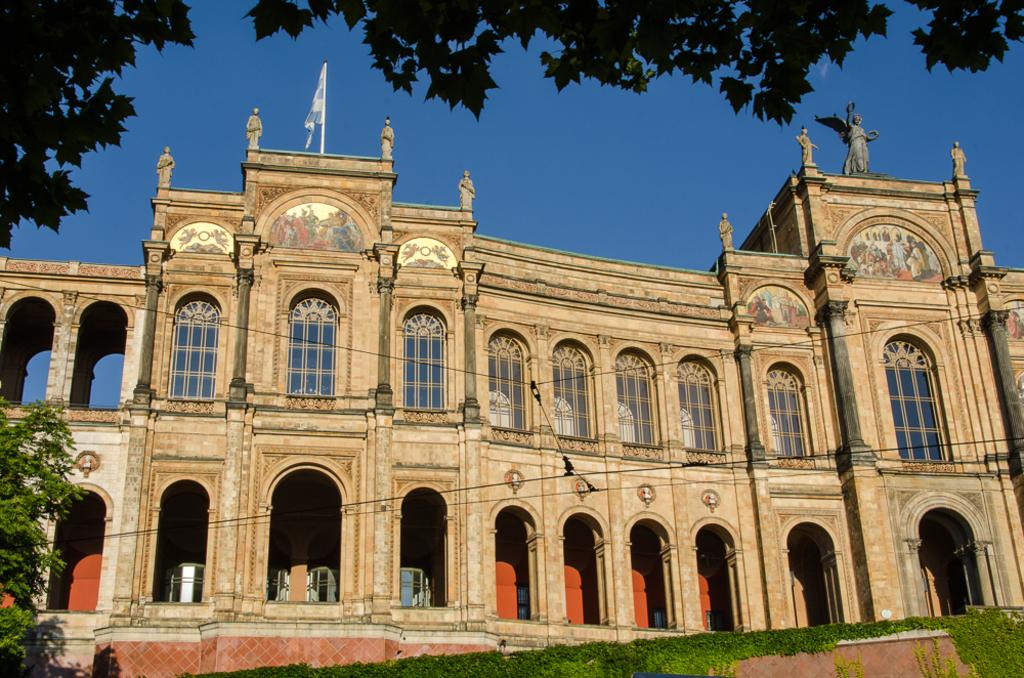What type of structure is in the picture? There is a building in the picture. What features can be seen on the building? The building has windows and doors. What additional elements are present in the picture? There is a flag, a statue, trees, and the sky visible in the picture. What is the ground like in the picture? The ground with grass is visible in the picture. What type of stocking is hanging from the building in the picture? There is no stocking present in the image; it only features a building, windows, doors, a flag, a statue, trees, the ground with grass, and the sky. 